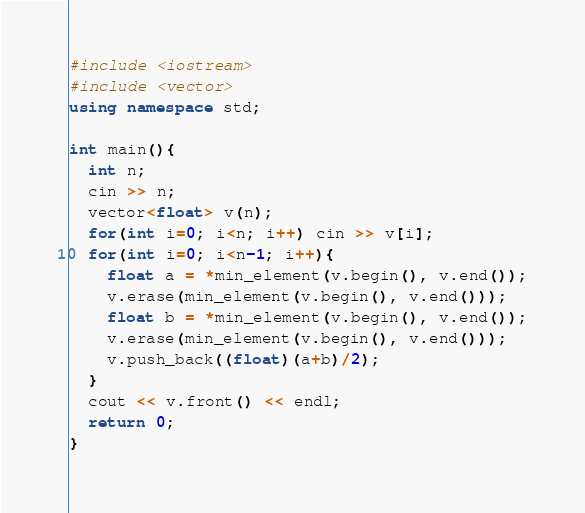<code> <loc_0><loc_0><loc_500><loc_500><_C++_>#include <iostream>
#include <vector>
using namespace std;

int main(){
  int n;
  cin >> n;
  vector<float> v(n);
  for(int i=0; i<n; i++) cin >> v[i];
  for(int i=0; i<n-1; i++){
    float a = *min_element(v.begin(), v.end());
    v.erase(min_element(v.begin(), v.end()));
    float b = *min_element(v.begin(), v.end());
    v.erase(min_element(v.begin(), v.end()));
    v.push_back((float)(a+b)/2);
  }
  cout << v.front() << endl;
  return 0;
}</code> 